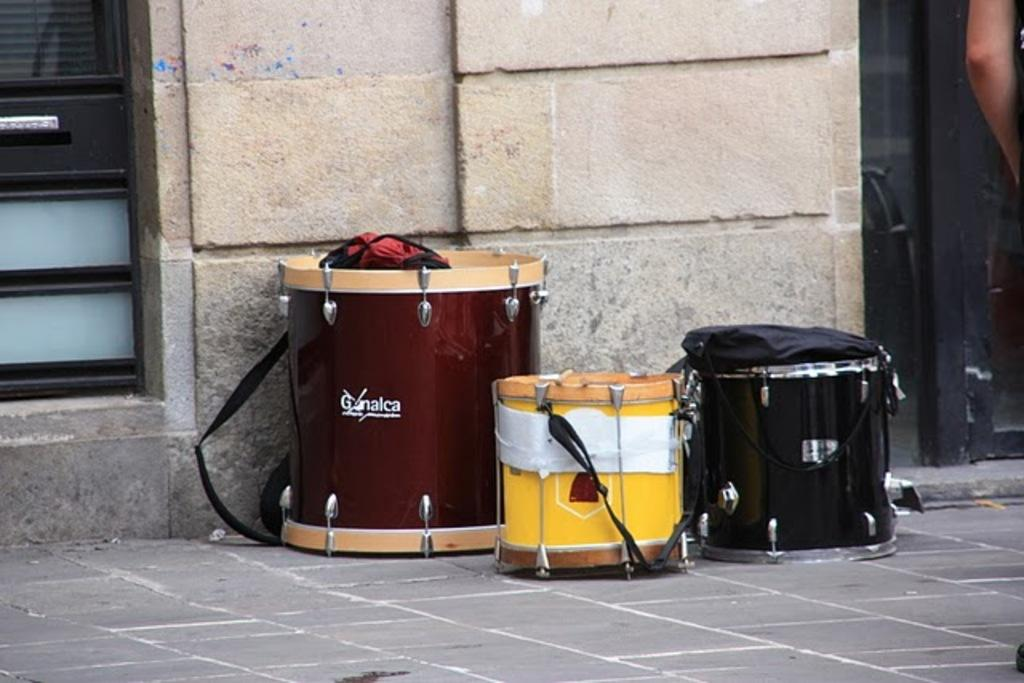<image>
Create a compact narrative representing the image presented. A drum set is on the pavement and the tallest one says Gonalca. 